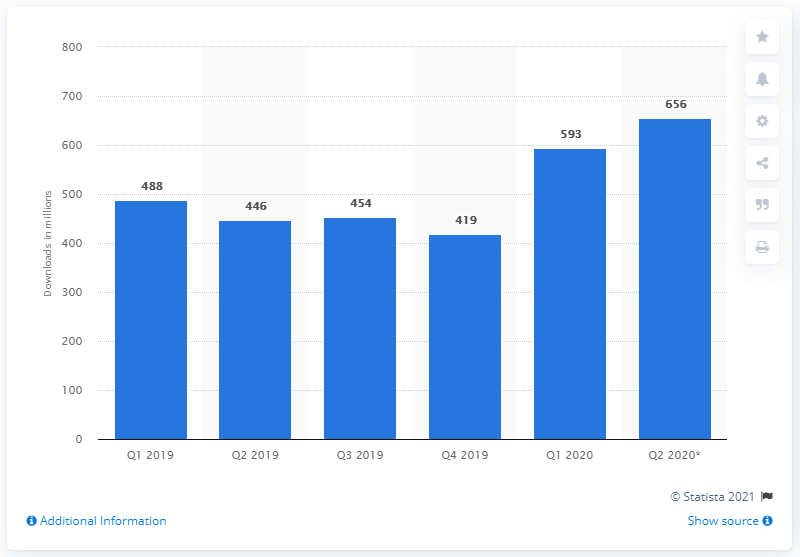List a handful of essential elements in this visual. In the first quarter of 2020, a total of 593 health and fitness apps were downloaded. In the same quarter of the previous year, a total of 446 times, health and fitness apps were downloaded. It is predicted that by the end of the second quarter of 2020, a total of 656 health and fitness apps will be downloaded. 